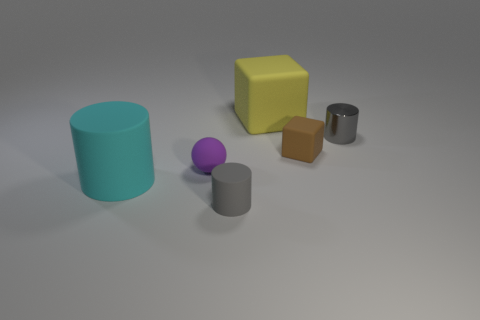How many large cylinders are the same color as the metal thing? There are no large cylinders sharing the color of the metal cylinder. In the image, we see various objects, including cylinders, a cube, and a sphere in an assortment of colors, but none of the larger cylinders match the color of the metal one. 